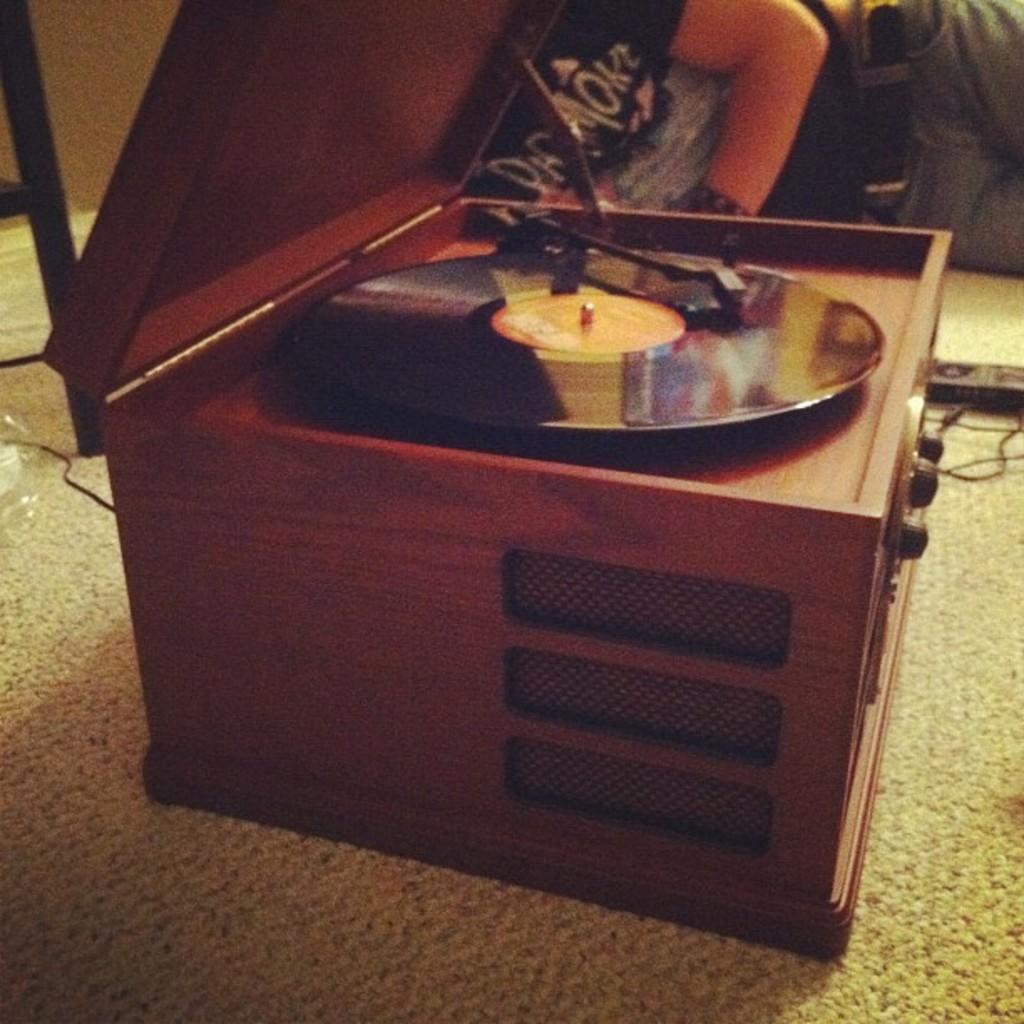Could you give a brief overview of what you see in this image? In this image i can see a music box with wooden kept on the floor and on the right corner i can see a person sat on the floor and wearing black color t- shirt 